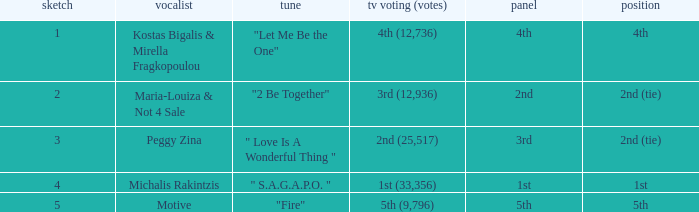The song "2 Be Together" had what jury? 2nd. 